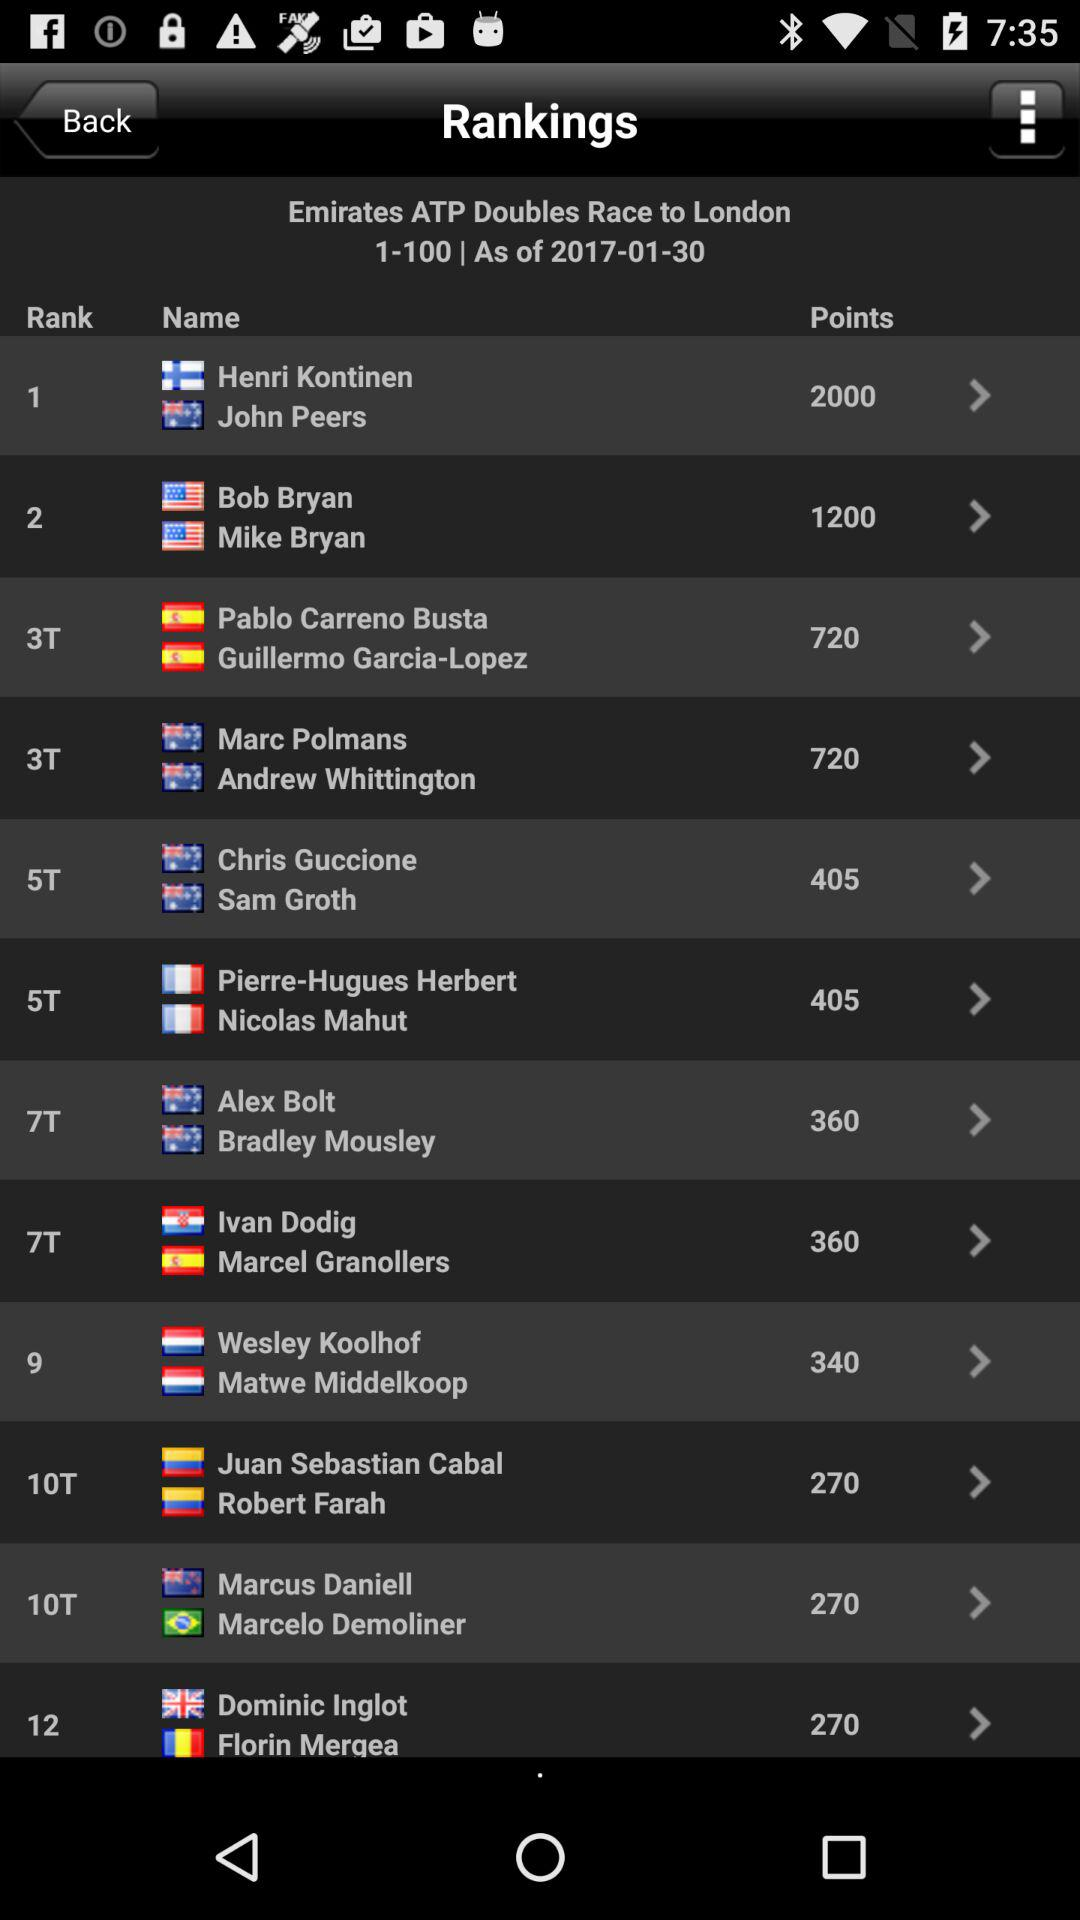What are the points of Henri Kontinen and John Peers? There are 2000 points. 